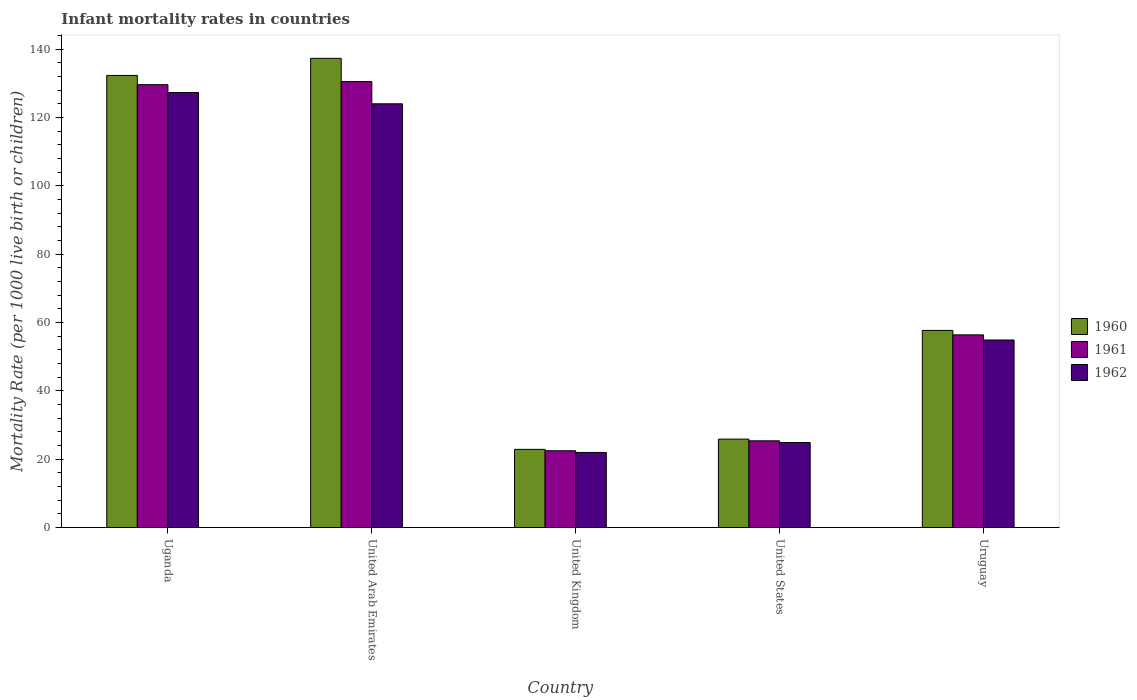Are the number of bars on each tick of the X-axis equal?
Your response must be concise. Yes. How many bars are there on the 3rd tick from the right?
Your response must be concise. 3. What is the label of the 1st group of bars from the left?
Your answer should be very brief. Uganda. In how many cases, is the number of bars for a given country not equal to the number of legend labels?
Your answer should be compact. 0. What is the infant mortality rate in 1962 in United Kingdom?
Provide a succinct answer. 22. Across all countries, what is the maximum infant mortality rate in 1962?
Offer a terse response. 127.3. Across all countries, what is the minimum infant mortality rate in 1960?
Keep it short and to the point. 22.9. In which country was the infant mortality rate in 1961 maximum?
Your answer should be compact. United Arab Emirates. In which country was the infant mortality rate in 1960 minimum?
Give a very brief answer. United Kingdom. What is the total infant mortality rate in 1962 in the graph?
Provide a succinct answer. 353.1. What is the difference between the infant mortality rate in 1960 in United Arab Emirates and that in United Kingdom?
Provide a short and direct response. 114.4. What is the difference between the infant mortality rate in 1961 in United States and the infant mortality rate in 1960 in United Arab Emirates?
Your answer should be very brief. -111.9. What is the average infant mortality rate in 1960 per country?
Provide a succinct answer. 75.22. What is the difference between the infant mortality rate of/in 1960 and infant mortality rate of/in 1961 in Uruguay?
Keep it short and to the point. 1.3. What is the ratio of the infant mortality rate in 1962 in United States to that in Uruguay?
Ensure brevity in your answer.  0.45. Is the difference between the infant mortality rate in 1960 in Uganda and Uruguay greater than the difference between the infant mortality rate in 1961 in Uganda and Uruguay?
Make the answer very short. Yes. What is the difference between the highest and the second highest infant mortality rate in 1962?
Give a very brief answer. 69.1. What is the difference between the highest and the lowest infant mortality rate in 1962?
Ensure brevity in your answer.  105.3. Is the sum of the infant mortality rate in 1960 in Uganda and United States greater than the maximum infant mortality rate in 1961 across all countries?
Your answer should be compact. Yes. What does the 2nd bar from the left in Uruguay represents?
Offer a terse response. 1961. What does the 1st bar from the right in Uruguay represents?
Offer a terse response. 1962. Is it the case that in every country, the sum of the infant mortality rate in 1960 and infant mortality rate in 1962 is greater than the infant mortality rate in 1961?
Your answer should be very brief. Yes. Are all the bars in the graph horizontal?
Provide a succinct answer. No. What is the difference between two consecutive major ticks on the Y-axis?
Provide a short and direct response. 20. Does the graph contain any zero values?
Provide a succinct answer. No. Does the graph contain grids?
Make the answer very short. No. Where does the legend appear in the graph?
Provide a succinct answer. Center right. How are the legend labels stacked?
Make the answer very short. Vertical. What is the title of the graph?
Your answer should be very brief. Infant mortality rates in countries. Does "1993" appear as one of the legend labels in the graph?
Ensure brevity in your answer.  No. What is the label or title of the Y-axis?
Offer a terse response. Mortality Rate (per 1000 live birth or children). What is the Mortality Rate (per 1000 live birth or children) of 1960 in Uganda?
Your answer should be compact. 132.3. What is the Mortality Rate (per 1000 live birth or children) in 1961 in Uganda?
Provide a short and direct response. 129.6. What is the Mortality Rate (per 1000 live birth or children) in 1962 in Uganda?
Your answer should be compact. 127.3. What is the Mortality Rate (per 1000 live birth or children) of 1960 in United Arab Emirates?
Ensure brevity in your answer.  137.3. What is the Mortality Rate (per 1000 live birth or children) in 1961 in United Arab Emirates?
Keep it short and to the point. 130.5. What is the Mortality Rate (per 1000 live birth or children) in 1962 in United Arab Emirates?
Provide a short and direct response. 124. What is the Mortality Rate (per 1000 live birth or children) of 1960 in United Kingdom?
Ensure brevity in your answer.  22.9. What is the Mortality Rate (per 1000 live birth or children) of 1962 in United Kingdom?
Ensure brevity in your answer.  22. What is the Mortality Rate (per 1000 live birth or children) in 1960 in United States?
Offer a very short reply. 25.9. What is the Mortality Rate (per 1000 live birth or children) of 1961 in United States?
Make the answer very short. 25.4. What is the Mortality Rate (per 1000 live birth or children) of 1962 in United States?
Give a very brief answer. 24.9. What is the Mortality Rate (per 1000 live birth or children) in 1960 in Uruguay?
Keep it short and to the point. 57.7. What is the Mortality Rate (per 1000 live birth or children) of 1961 in Uruguay?
Your answer should be compact. 56.4. What is the Mortality Rate (per 1000 live birth or children) in 1962 in Uruguay?
Provide a short and direct response. 54.9. Across all countries, what is the maximum Mortality Rate (per 1000 live birth or children) of 1960?
Ensure brevity in your answer.  137.3. Across all countries, what is the maximum Mortality Rate (per 1000 live birth or children) in 1961?
Offer a very short reply. 130.5. Across all countries, what is the maximum Mortality Rate (per 1000 live birth or children) in 1962?
Offer a terse response. 127.3. Across all countries, what is the minimum Mortality Rate (per 1000 live birth or children) of 1960?
Give a very brief answer. 22.9. Across all countries, what is the minimum Mortality Rate (per 1000 live birth or children) in 1962?
Keep it short and to the point. 22. What is the total Mortality Rate (per 1000 live birth or children) of 1960 in the graph?
Keep it short and to the point. 376.1. What is the total Mortality Rate (per 1000 live birth or children) in 1961 in the graph?
Your answer should be compact. 364.4. What is the total Mortality Rate (per 1000 live birth or children) in 1962 in the graph?
Offer a very short reply. 353.1. What is the difference between the Mortality Rate (per 1000 live birth or children) in 1962 in Uganda and that in United Arab Emirates?
Your answer should be compact. 3.3. What is the difference between the Mortality Rate (per 1000 live birth or children) of 1960 in Uganda and that in United Kingdom?
Offer a very short reply. 109.4. What is the difference between the Mortality Rate (per 1000 live birth or children) in 1961 in Uganda and that in United Kingdom?
Provide a succinct answer. 107.1. What is the difference between the Mortality Rate (per 1000 live birth or children) of 1962 in Uganda and that in United Kingdom?
Your answer should be compact. 105.3. What is the difference between the Mortality Rate (per 1000 live birth or children) of 1960 in Uganda and that in United States?
Keep it short and to the point. 106.4. What is the difference between the Mortality Rate (per 1000 live birth or children) in 1961 in Uganda and that in United States?
Give a very brief answer. 104.2. What is the difference between the Mortality Rate (per 1000 live birth or children) in 1962 in Uganda and that in United States?
Ensure brevity in your answer.  102.4. What is the difference between the Mortality Rate (per 1000 live birth or children) in 1960 in Uganda and that in Uruguay?
Provide a succinct answer. 74.6. What is the difference between the Mortality Rate (per 1000 live birth or children) in 1961 in Uganda and that in Uruguay?
Ensure brevity in your answer.  73.2. What is the difference between the Mortality Rate (per 1000 live birth or children) in 1962 in Uganda and that in Uruguay?
Make the answer very short. 72.4. What is the difference between the Mortality Rate (per 1000 live birth or children) of 1960 in United Arab Emirates and that in United Kingdom?
Provide a succinct answer. 114.4. What is the difference between the Mortality Rate (per 1000 live birth or children) in 1961 in United Arab Emirates and that in United Kingdom?
Ensure brevity in your answer.  108. What is the difference between the Mortality Rate (per 1000 live birth or children) of 1962 in United Arab Emirates and that in United Kingdom?
Make the answer very short. 102. What is the difference between the Mortality Rate (per 1000 live birth or children) of 1960 in United Arab Emirates and that in United States?
Ensure brevity in your answer.  111.4. What is the difference between the Mortality Rate (per 1000 live birth or children) of 1961 in United Arab Emirates and that in United States?
Give a very brief answer. 105.1. What is the difference between the Mortality Rate (per 1000 live birth or children) of 1962 in United Arab Emirates and that in United States?
Provide a short and direct response. 99.1. What is the difference between the Mortality Rate (per 1000 live birth or children) in 1960 in United Arab Emirates and that in Uruguay?
Keep it short and to the point. 79.6. What is the difference between the Mortality Rate (per 1000 live birth or children) in 1961 in United Arab Emirates and that in Uruguay?
Your response must be concise. 74.1. What is the difference between the Mortality Rate (per 1000 live birth or children) of 1962 in United Arab Emirates and that in Uruguay?
Provide a short and direct response. 69.1. What is the difference between the Mortality Rate (per 1000 live birth or children) of 1962 in United Kingdom and that in United States?
Your answer should be very brief. -2.9. What is the difference between the Mortality Rate (per 1000 live birth or children) of 1960 in United Kingdom and that in Uruguay?
Your answer should be very brief. -34.8. What is the difference between the Mortality Rate (per 1000 live birth or children) of 1961 in United Kingdom and that in Uruguay?
Offer a very short reply. -33.9. What is the difference between the Mortality Rate (per 1000 live birth or children) of 1962 in United Kingdom and that in Uruguay?
Keep it short and to the point. -32.9. What is the difference between the Mortality Rate (per 1000 live birth or children) in 1960 in United States and that in Uruguay?
Offer a very short reply. -31.8. What is the difference between the Mortality Rate (per 1000 live birth or children) in 1961 in United States and that in Uruguay?
Offer a terse response. -31. What is the difference between the Mortality Rate (per 1000 live birth or children) of 1962 in United States and that in Uruguay?
Ensure brevity in your answer.  -30. What is the difference between the Mortality Rate (per 1000 live birth or children) in 1960 in Uganda and the Mortality Rate (per 1000 live birth or children) in 1961 in United Arab Emirates?
Provide a succinct answer. 1.8. What is the difference between the Mortality Rate (per 1000 live birth or children) in 1961 in Uganda and the Mortality Rate (per 1000 live birth or children) in 1962 in United Arab Emirates?
Ensure brevity in your answer.  5.6. What is the difference between the Mortality Rate (per 1000 live birth or children) in 1960 in Uganda and the Mortality Rate (per 1000 live birth or children) in 1961 in United Kingdom?
Offer a terse response. 109.8. What is the difference between the Mortality Rate (per 1000 live birth or children) of 1960 in Uganda and the Mortality Rate (per 1000 live birth or children) of 1962 in United Kingdom?
Make the answer very short. 110.3. What is the difference between the Mortality Rate (per 1000 live birth or children) of 1961 in Uganda and the Mortality Rate (per 1000 live birth or children) of 1962 in United Kingdom?
Provide a succinct answer. 107.6. What is the difference between the Mortality Rate (per 1000 live birth or children) of 1960 in Uganda and the Mortality Rate (per 1000 live birth or children) of 1961 in United States?
Offer a very short reply. 106.9. What is the difference between the Mortality Rate (per 1000 live birth or children) of 1960 in Uganda and the Mortality Rate (per 1000 live birth or children) of 1962 in United States?
Offer a terse response. 107.4. What is the difference between the Mortality Rate (per 1000 live birth or children) in 1961 in Uganda and the Mortality Rate (per 1000 live birth or children) in 1962 in United States?
Give a very brief answer. 104.7. What is the difference between the Mortality Rate (per 1000 live birth or children) in 1960 in Uganda and the Mortality Rate (per 1000 live birth or children) in 1961 in Uruguay?
Your response must be concise. 75.9. What is the difference between the Mortality Rate (per 1000 live birth or children) of 1960 in Uganda and the Mortality Rate (per 1000 live birth or children) of 1962 in Uruguay?
Offer a very short reply. 77.4. What is the difference between the Mortality Rate (per 1000 live birth or children) in 1961 in Uganda and the Mortality Rate (per 1000 live birth or children) in 1962 in Uruguay?
Your answer should be compact. 74.7. What is the difference between the Mortality Rate (per 1000 live birth or children) of 1960 in United Arab Emirates and the Mortality Rate (per 1000 live birth or children) of 1961 in United Kingdom?
Give a very brief answer. 114.8. What is the difference between the Mortality Rate (per 1000 live birth or children) of 1960 in United Arab Emirates and the Mortality Rate (per 1000 live birth or children) of 1962 in United Kingdom?
Make the answer very short. 115.3. What is the difference between the Mortality Rate (per 1000 live birth or children) of 1961 in United Arab Emirates and the Mortality Rate (per 1000 live birth or children) of 1962 in United Kingdom?
Provide a short and direct response. 108.5. What is the difference between the Mortality Rate (per 1000 live birth or children) of 1960 in United Arab Emirates and the Mortality Rate (per 1000 live birth or children) of 1961 in United States?
Ensure brevity in your answer.  111.9. What is the difference between the Mortality Rate (per 1000 live birth or children) of 1960 in United Arab Emirates and the Mortality Rate (per 1000 live birth or children) of 1962 in United States?
Make the answer very short. 112.4. What is the difference between the Mortality Rate (per 1000 live birth or children) in 1961 in United Arab Emirates and the Mortality Rate (per 1000 live birth or children) in 1962 in United States?
Provide a short and direct response. 105.6. What is the difference between the Mortality Rate (per 1000 live birth or children) in 1960 in United Arab Emirates and the Mortality Rate (per 1000 live birth or children) in 1961 in Uruguay?
Your answer should be compact. 80.9. What is the difference between the Mortality Rate (per 1000 live birth or children) in 1960 in United Arab Emirates and the Mortality Rate (per 1000 live birth or children) in 1962 in Uruguay?
Keep it short and to the point. 82.4. What is the difference between the Mortality Rate (per 1000 live birth or children) of 1961 in United Arab Emirates and the Mortality Rate (per 1000 live birth or children) of 1962 in Uruguay?
Your answer should be compact. 75.6. What is the difference between the Mortality Rate (per 1000 live birth or children) in 1960 in United Kingdom and the Mortality Rate (per 1000 live birth or children) in 1961 in United States?
Your answer should be very brief. -2.5. What is the difference between the Mortality Rate (per 1000 live birth or children) of 1960 in United Kingdom and the Mortality Rate (per 1000 live birth or children) of 1962 in United States?
Give a very brief answer. -2. What is the difference between the Mortality Rate (per 1000 live birth or children) in 1961 in United Kingdom and the Mortality Rate (per 1000 live birth or children) in 1962 in United States?
Offer a terse response. -2.4. What is the difference between the Mortality Rate (per 1000 live birth or children) in 1960 in United Kingdom and the Mortality Rate (per 1000 live birth or children) in 1961 in Uruguay?
Keep it short and to the point. -33.5. What is the difference between the Mortality Rate (per 1000 live birth or children) of 1960 in United Kingdom and the Mortality Rate (per 1000 live birth or children) of 1962 in Uruguay?
Ensure brevity in your answer.  -32. What is the difference between the Mortality Rate (per 1000 live birth or children) in 1961 in United Kingdom and the Mortality Rate (per 1000 live birth or children) in 1962 in Uruguay?
Your answer should be very brief. -32.4. What is the difference between the Mortality Rate (per 1000 live birth or children) of 1960 in United States and the Mortality Rate (per 1000 live birth or children) of 1961 in Uruguay?
Offer a terse response. -30.5. What is the difference between the Mortality Rate (per 1000 live birth or children) of 1960 in United States and the Mortality Rate (per 1000 live birth or children) of 1962 in Uruguay?
Your answer should be very brief. -29. What is the difference between the Mortality Rate (per 1000 live birth or children) in 1961 in United States and the Mortality Rate (per 1000 live birth or children) in 1962 in Uruguay?
Provide a short and direct response. -29.5. What is the average Mortality Rate (per 1000 live birth or children) in 1960 per country?
Your response must be concise. 75.22. What is the average Mortality Rate (per 1000 live birth or children) of 1961 per country?
Give a very brief answer. 72.88. What is the average Mortality Rate (per 1000 live birth or children) of 1962 per country?
Offer a terse response. 70.62. What is the difference between the Mortality Rate (per 1000 live birth or children) in 1960 and Mortality Rate (per 1000 live birth or children) in 1962 in Uganda?
Provide a short and direct response. 5. What is the difference between the Mortality Rate (per 1000 live birth or children) of 1960 and Mortality Rate (per 1000 live birth or children) of 1962 in United Arab Emirates?
Offer a very short reply. 13.3. What is the difference between the Mortality Rate (per 1000 live birth or children) in 1961 and Mortality Rate (per 1000 live birth or children) in 1962 in United Arab Emirates?
Your answer should be compact. 6.5. What is the difference between the Mortality Rate (per 1000 live birth or children) of 1961 and Mortality Rate (per 1000 live birth or children) of 1962 in United Kingdom?
Your response must be concise. 0.5. What is the difference between the Mortality Rate (per 1000 live birth or children) of 1960 and Mortality Rate (per 1000 live birth or children) of 1961 in United States?
Give a very brief answer. 0.5. What is the difference between the Mortality Rate (per 1000 live birth or children) of 1961 and Mortality Rate (per 1000 live birth or children) of 1962 in United States?
Provide a succinct answer. 0.5. What is the difference between the Mortality Rate (per 1000 live birth or children) in 1960 and Mortality Rate (per 1000 live birth or children) in 1961 in Uruguay?
Your answer should be compact. 1.3. What is the ratio of the Mortality Rate (per 1000 live birth or children) in 1960 in Uganda to that in United Arab Emirates?
Provide a short and direct response. 0.96. What is the ratio of the Mortality Rate (per 1000 live birth or children) in 1962 in Uganda to that in United Arab Emirates?
Keep it short and to the point. 1.03. What is the ratio of the Mortality Rate (per 1000 live birth or children) of 1960 in Uganda to that in United Kingdom?
Make the answer very short. 5.78. What is the ratio of the Mortality Rate (per 1000 live birth or children) of 1961 in Uganda to that in United Kingdom?
Make the answer very short. 5.76. What is the ratio of the Mortality Rate (per 1000 live birth or children) of 1962 in Uganda to that in United Kingdom?
Provide a short and direct response. 5.79. What is the ratio of the Mortality Rate (per 1000 live birth or children) in 1960 in Uganda to that in United States?
Your answer should be very brief. 5.11. What is the ratio of the Mortality Rate (per 1000 live birth or children) of 1961 in Uganda to that in United States?
Your response must be concise. 5.1. What is the ratio of the Mortality Rate (per 1000 live birth or children) of 1962 in Uganda to that in United States?
Ensure brevity in your answer.  5.11. What is the ratio of the Mortality Rate (per 1000 live birth or children) of 1960 in Uganda to that in Uruguay?
Ensure brevity in your answer.  2.29. What is the ratio of the Mortality Rate (per 1000 live birth or children) of 1961 in Uganda to that in Uruguay?
Your answer should be very brief. 2.3. What is the ratio of the Mortality Rate (per 1000 live birth or children) of 1962 in Uganda to that in Uruguay?
Make the answer very short. 2.32. What is the ratio of the Mortality Rate (per 1000 live birth or children) in 1960 in United Arab Emirates to that in United Kingdom?
Ensure brevity in your answer.  6. What is the ratio of the Mortality Rate (per 1000 live birth or children) of 1962 in United Arab Emirates to that in United Kingdom?
Offer a very short reply. 5.64. What is the ratio of the Mortality Rate (per 1000 live birth or children) in 1960 in United Arab Emirates to that in United States?
Keep it short and to the point. 5.3. What is the ratio of the Mortality Rate (per 1000 live birth or children) in 1961 in United Arab Emirates to that in United States?
Offer a very short reply. 5.14. What is the ratio of the Mortality Rate (per 1000 live birth or children) in 1962 in United Arab Emirates to that in United States?
Provide a succinct answer. 4.98. What is the ratio of the Mortality Rate (per 1000 live birth or children) in 1960 in United Arab Emirates to that in Uruguay?
Give a very brief answer. 2.38. What is the ratio of the Mortality Rate (per 1000 live birth or children) of 1961 in United Arab Emirates to that in Uruguay?
Offer a terse response. 2.31. What is the ratio of the Mortality Rate (per 1000 live birth or children) in 1962 in United Arab Emirates to that in Uruguay?
Your answer should be very brief. 2.26. What is the ratio of the Mortality Rate (per 1000 live birth or children) of 1960 in United Kingdom to that in United States?
Give a very brief answer. 0.88. What is the ratio of the Mortality Rate (per 1000 live birth or children) of 1961 in United Kingdom to that in United States?
Provide a succinct answer. 0.89. What is the ratio of the Mortality Rate (per 1000 live birth or children) of 1962 in United Kingdom to that in United States?
Make the answer very short. 0.88. What is the ratio of the Mortality Rate (per 1000 live birth or children) of 1960 in United Kingdom to that in Uruguay?
Your answer should be very brief. 0.4. What is the ratio of the Mortality Rate (per 1000 live birth or children) in 1961 in United Kingdom to that in Uruguay?
Offer a terse response. 0.4. What is the ratio of the Mortality Rate (per 1000 live birth or children) in 1962 in United Kingdom to that in Uruguay?
Your answer should be very brief. 0.4. What is the ratio of the Mortality Rate (per 1000 live birth or children) in 1960 in United States to that in Uruguay?
Keep it short and to the point. 0.45. What is the ratio of the Mortality Rate (per 1000 live birth or children) in 1961 in United States to that in Uruguay?
Your answer should be very brief. 0.45. What is the ratio of the Mortality Rate (per 1000 live birth or children) in 1962 in United States to that in Uruguay?
Provide a short and direct response. 0.45. What is the difference between the highest and the second highest Mortality Rate (per 1000 live birth or children) of 1961?
Offer a terse response. 0.9. What is the difference between the highest and the second highest Mortality Rate (per 1000 live birth or children) in 1962?
Your answer should be very brief. 3.3. What is the difference between the highest and the lowest Mortality Rate (per 1000 live birth or children) in 1960?
Provide a short and direct response. 114.4. What is the difference between the highest and the lowest Mortality Rate (per 1000 live birth or children) of 1961?
Keep it short and to the point. 108. What is the difference between the highest and the lowest Mortality Rate (per 1000 live birth or children) in 1962?
Your response must be concise. 105.3. 